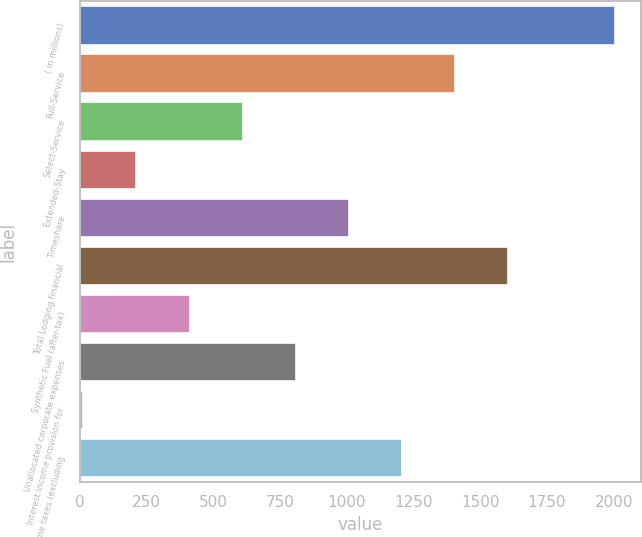Convert chart. <chart><loc_0><loc_0><loc_500><loc_500><bar_chart><fcel>( in millions)<fcel>Full-Service<fcel>Select-Service<fcel>Extended-Stay<fcel>Timeshare<fcel>Total Lodging financial<fcel>Synthetic Fuel (after-tax)<fcel>Unallocated corporate expenses<fcel>Interest income provision for<fcel>Income taxes (excluding<nl><fcel>2003<fcel>1405.7<fcel>609.3<fcel>211.1<fcel>1007.5<fcel>1604.8<fcel>410.2<fcel>808.4<fcel>12<fcel>1206.6<nl></chart> 